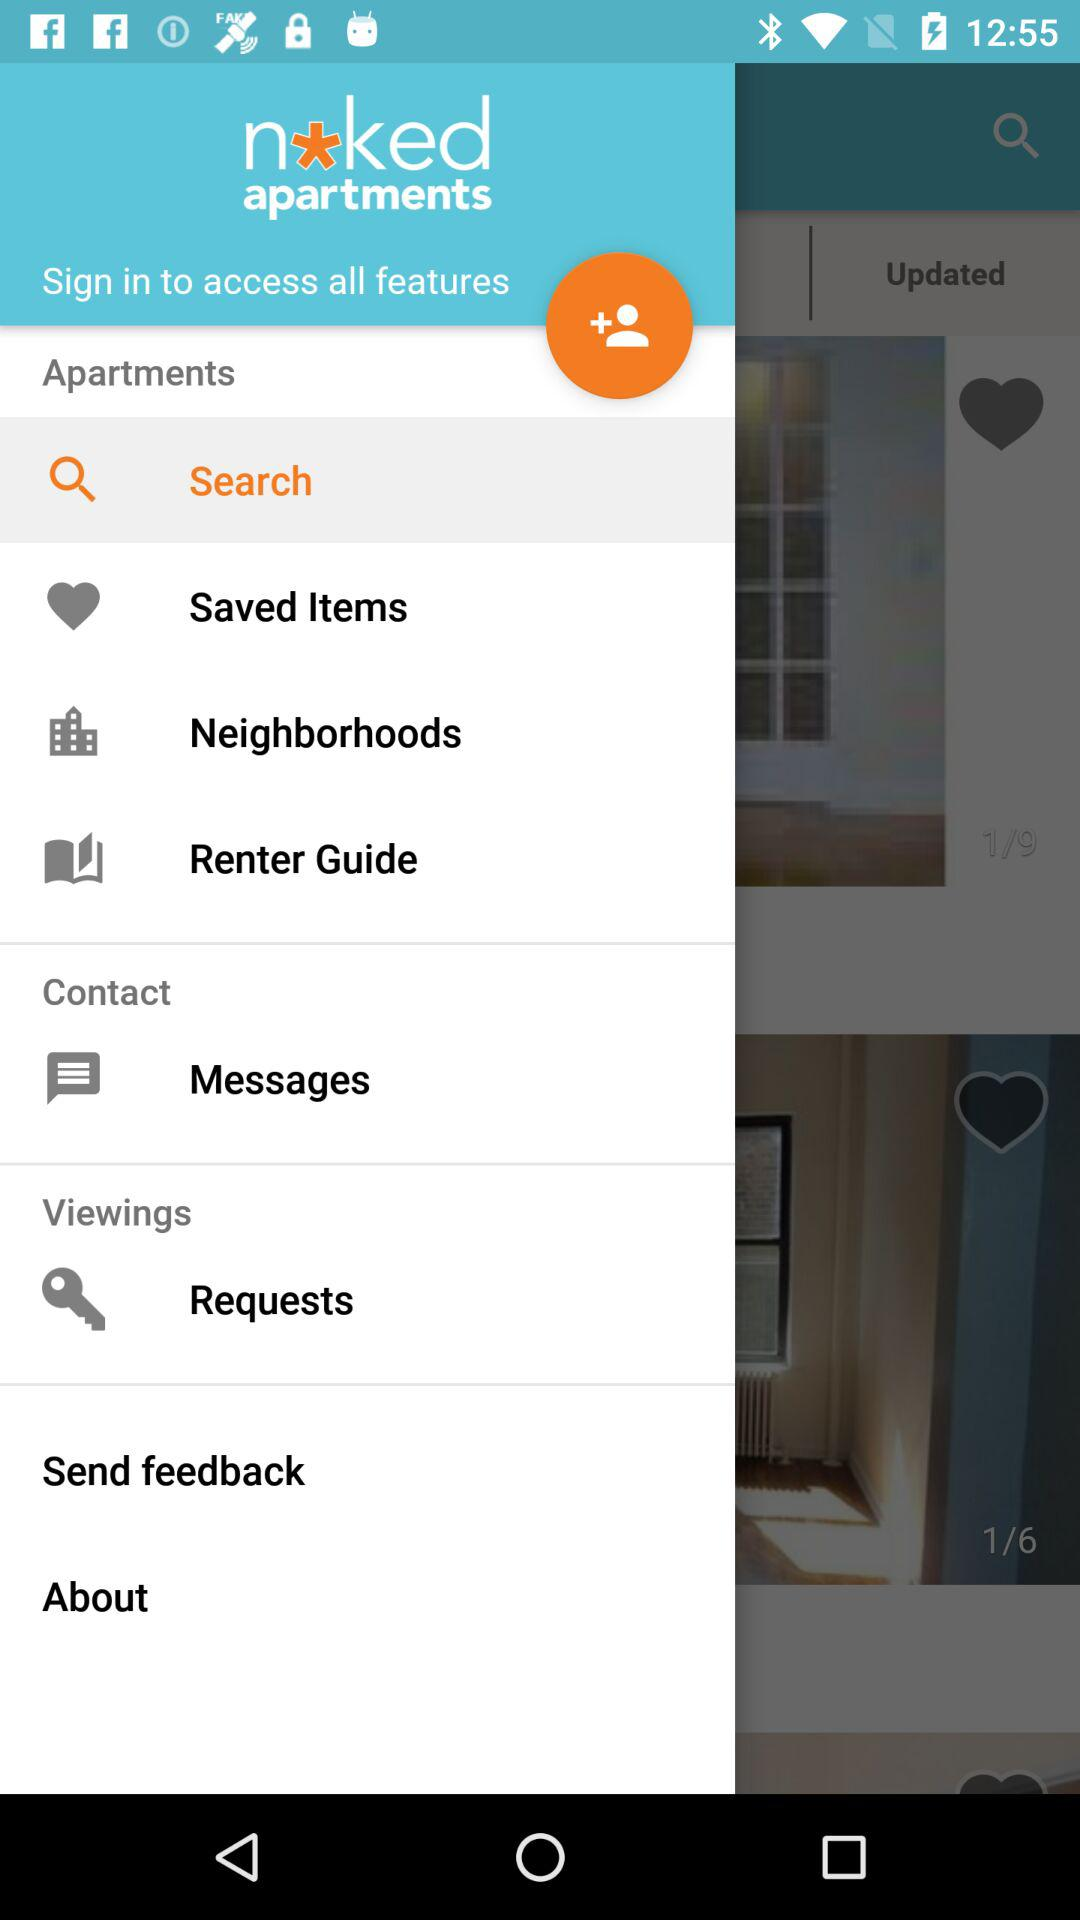How many unread messages are there?
When the provided information is insufficient, respond with <no answer>. <no answer> 